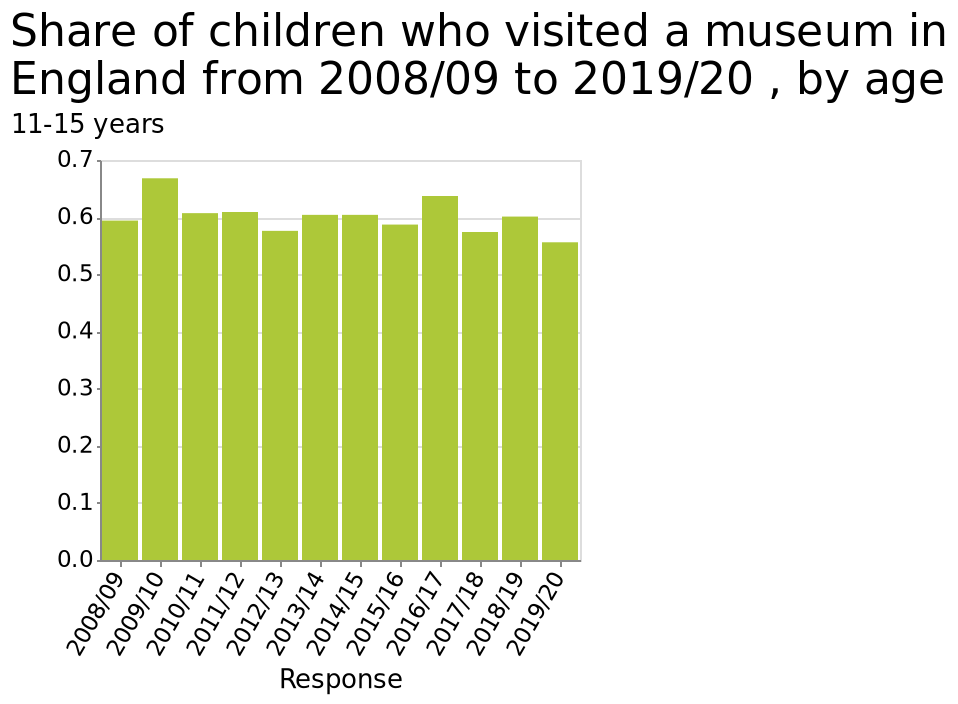<image>
What does the data show about the variation of responses throughout the years?  The data does not show much variation of responses throughout the years. please summary the statistics and relations of the chart The data does not show much variation of responses throughout the years. The graph shows the responses given are from the older children of the age gruoup. 